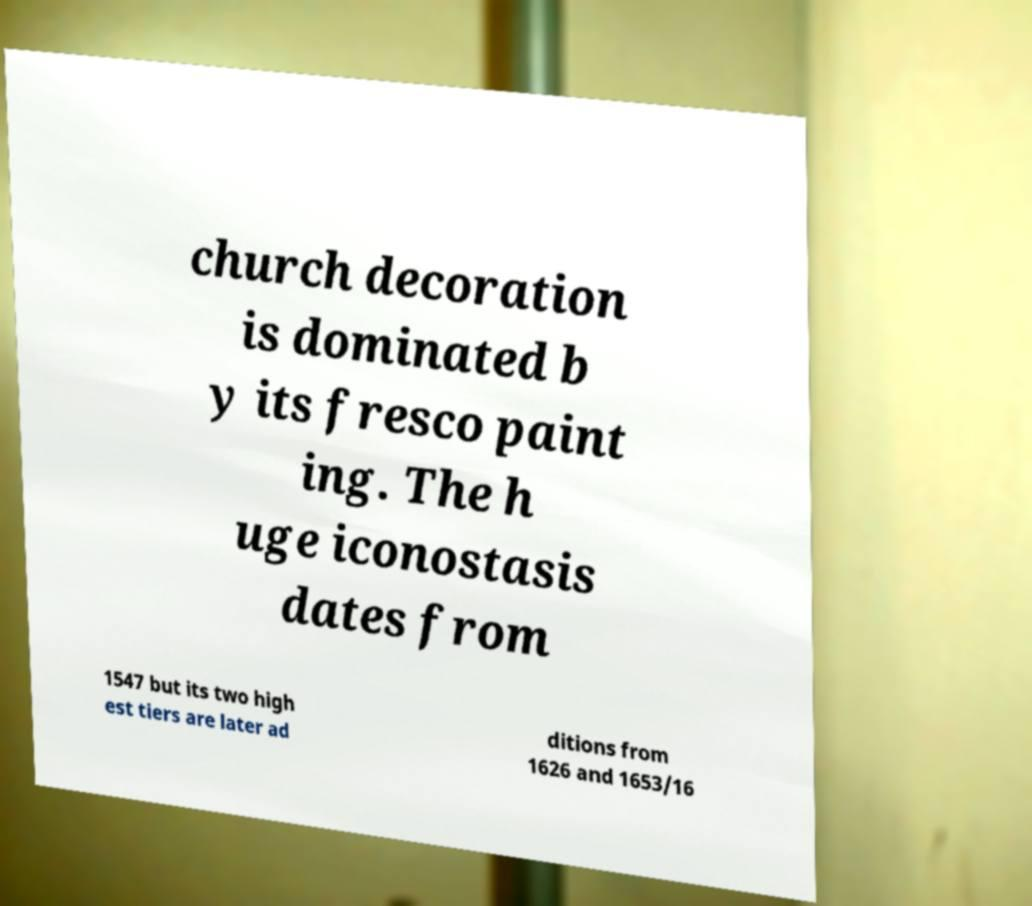Please identify and transcribe the text found in this image. church decoration is dominated b y its fresco paint ing. The h uge iconostasis dates from 1547 but its two high est tiers are later ad ditions from 1626 and 1653/16 